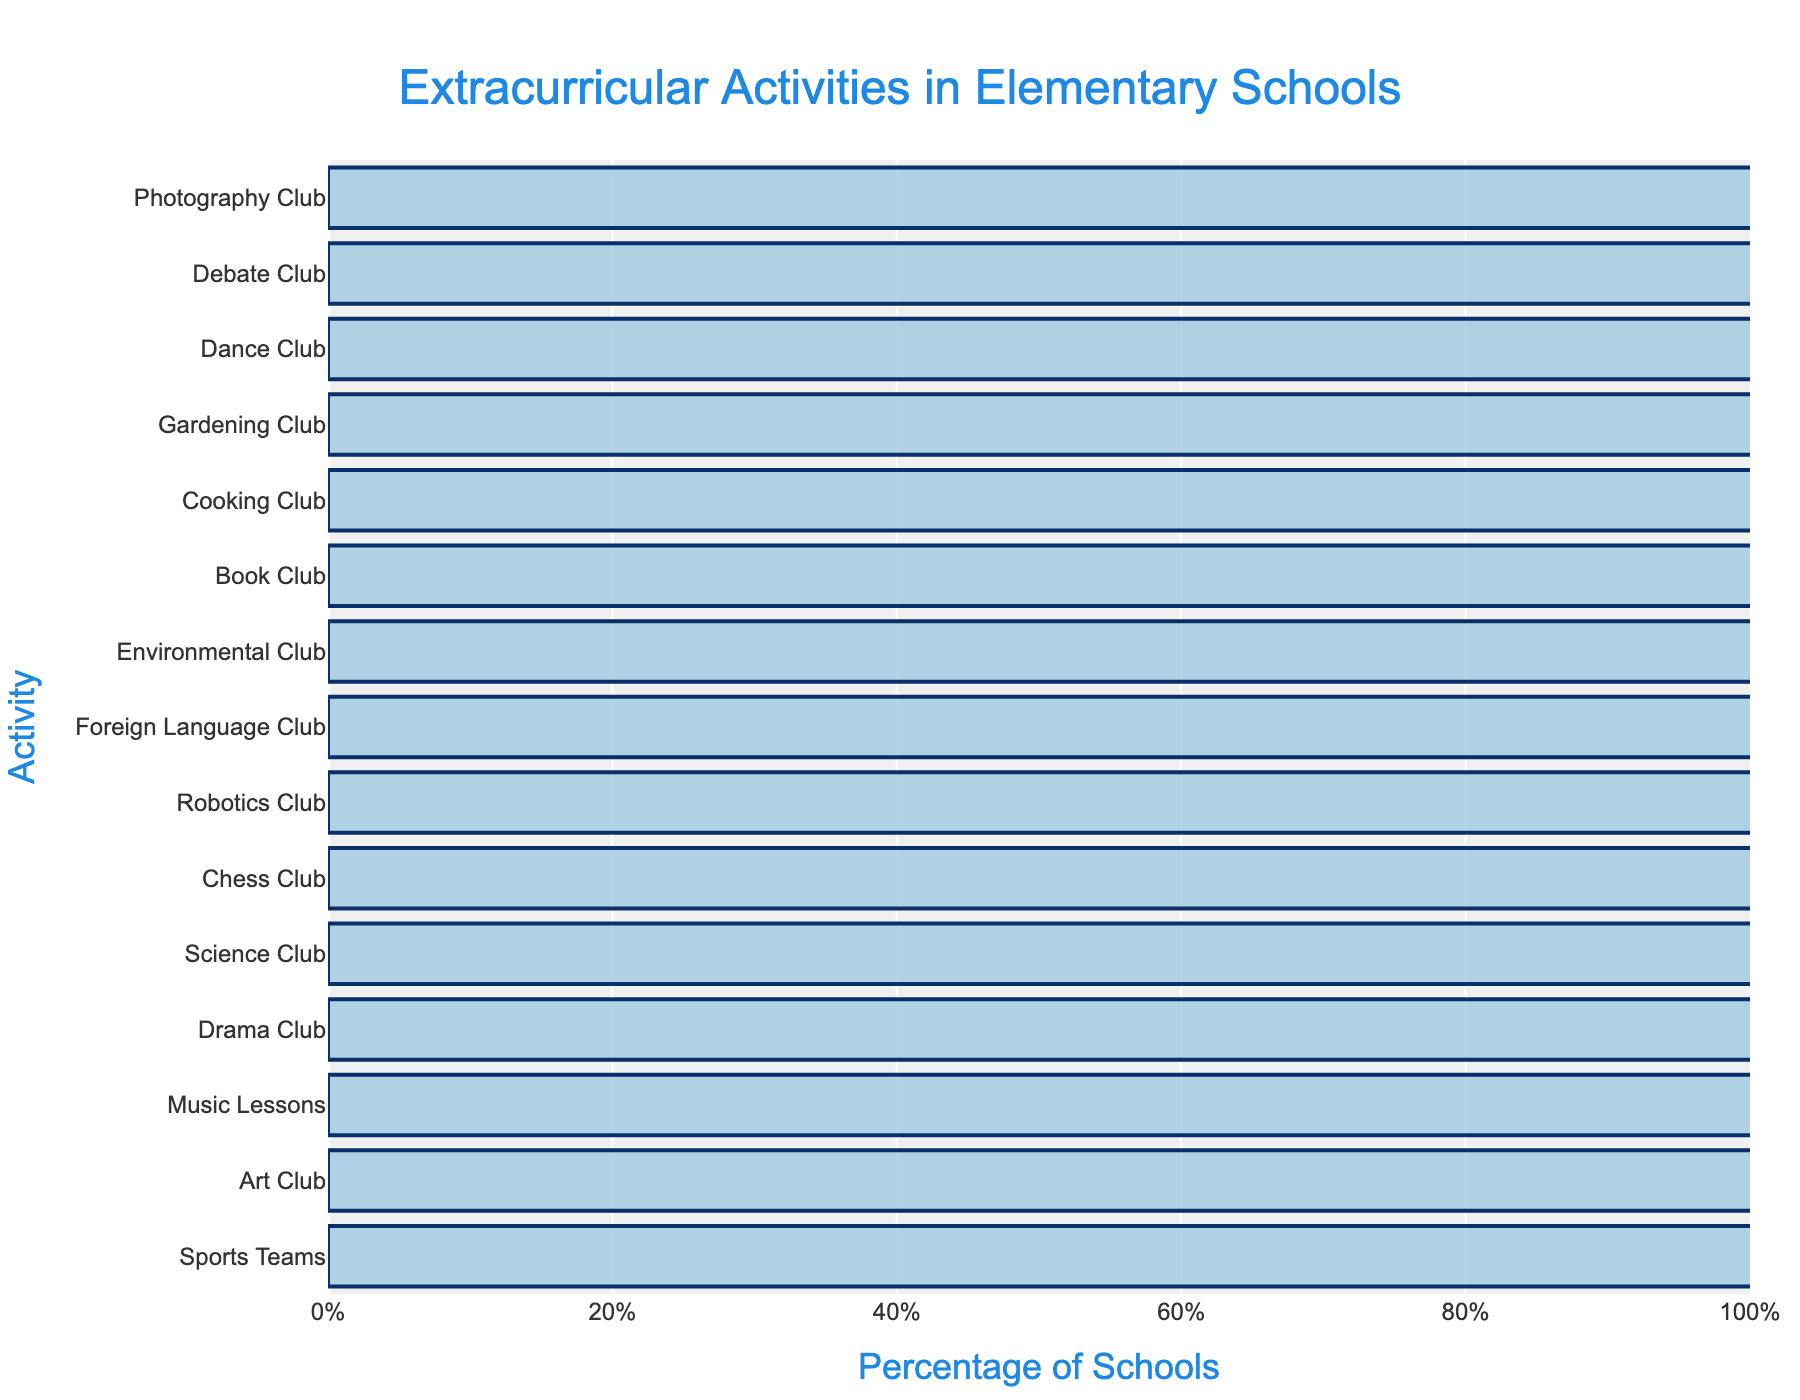Which extracurricular activity is offered by the highest percentage of schools? The chart shows the percentage of schools offering different activities. The tallest bar represents "Sports Teams" with 85%.
Answer: Sports Teams Which two extracurricular activities have the closest percentage of schools offering them? By comparing the heights of the bars, "Robotics Club" (30%) and "Foreign Language Club" (28%) have the closest percentages.
Answer: Robotics Club and Foreign Language Club What is the difference in the percentage of schools offering Music Lessons and Drama Club? Music Lessons are at 68%, and Drama Club is at 45%. The difference is 68% - 45% = 23%.
Answer: 23% List the activities that are offered by less than 20% of schools. The activities offered by less than 20% of schools are identified by the length of their bars being below the 20% mark: Cooking Club (18%), Gardening Club (15%), Dance Club (12%), Debate Club (10%), and Photography Club (8%).
Answer: Cooking Club, Gardening Club, Dance Club, Debate Club, Photography Club How many extracurricular activities are offered by less than 30% of schools? Counting the bars that are shorter than the 30% mark yields five activities: Robotics Club (30%), Foreign Language Club (28%), Environmental Club (25%), Book Club (22%), Cooking Club (18%), Gardening Club (15%), Dance Club (12%), Debate Club (10%), and Photography Club (8%). There are 9 activities in total.
Answer: 9 Which extracurricular activity is offered by the smallest percentage of schools? The shortest bar represents "Photography Club," which is offered by 8% of schools.
Answer: Photography Club What is the average percentage of schools offering the Science Club, Chess Club, and Robotics Club? The percentages for these activities are 40%, 35%, and 30%. The sum is 40% + 35% + 30% = 105%, and the average is 105%/3 = 35%.
Answer: 35% Compare the percentage of schools offering Sports Teams and Art Club. Is the percentage of schools offering Sports Teams more than double that of Art Club? Sports Teams are offered by 85% of schools, and Art Club by 72%. Double of 72% is 144%, which is more than 85%. Therefore, Sports Teams are not offered by more than double the percentage of schools compared to Art Club.
Answer: No What is the total percentage of schools offering either Science Club or Chess Club? Adding the percentages for Science Club (40%) and Chess Club (35%) gives 40% + 35% = 75%.
Answer: 75% 